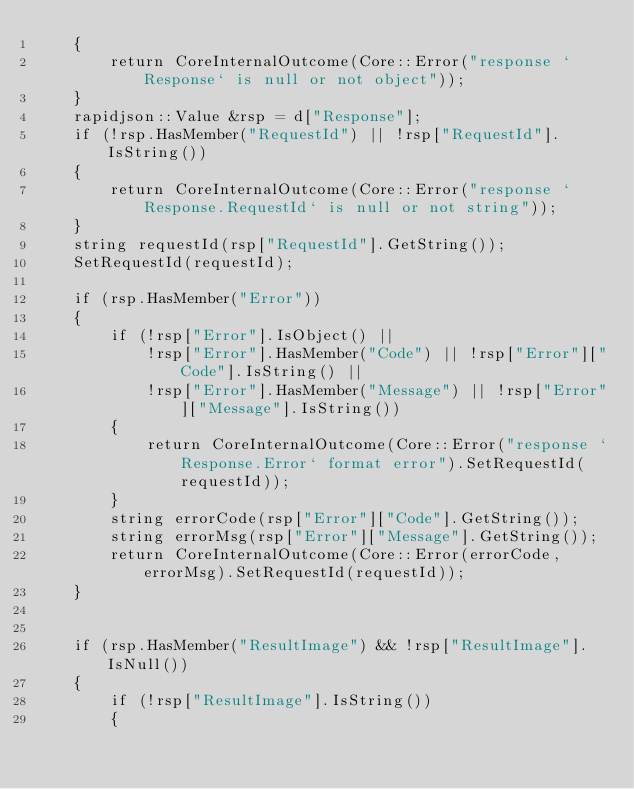<code> <loc_0><loc_0><loc_500><loc_500><_C++_>    {
        return CoreInternalOutcome(Core::Error("response `Response` is null or not object"));
    }
    rapidjson::Value &rsp = d["Response"];
    if (!rsp.HasMember("RequestId") || !rsp["RequestId"].IsString())
    {
        return CoreInternalOutcome(Core::Error("response `Response.RequestId` is null or not string"));
    }
    string requestId(rsp["RequestId"].GetString());
    SetRequestId(requestId);

    if (rsp.HasMember("Error"))
    {
        if (!rsp["Error"].IsObject() ||
            !rsp["Error"].HasMember("Code") || !rsp["Error"]["Code"].IsString() ||
            !rsp["Error"].HasMember("Message") || !rsp["Error"]["Message"].IsString())
        {
            return CoreInternalOutcome(Core::Error("response `Response.Error` format error").SetRequestId(requestId));
        }
        string errorCode(rsp["Error"]["Code"].GetString());
        string errorMsg(rsp["Error"]["Message"].GetString());
        return CoreInternalOutcome(Core::Error(errorCode, errorMsg).SetRequestId(requestId));
    }


    if (rsp.HasMember("ResultImage") && !rsp["ResultImage"].IsNull())
    {
        if (!rsp["ResultImage"].IsString())
        {</code> 